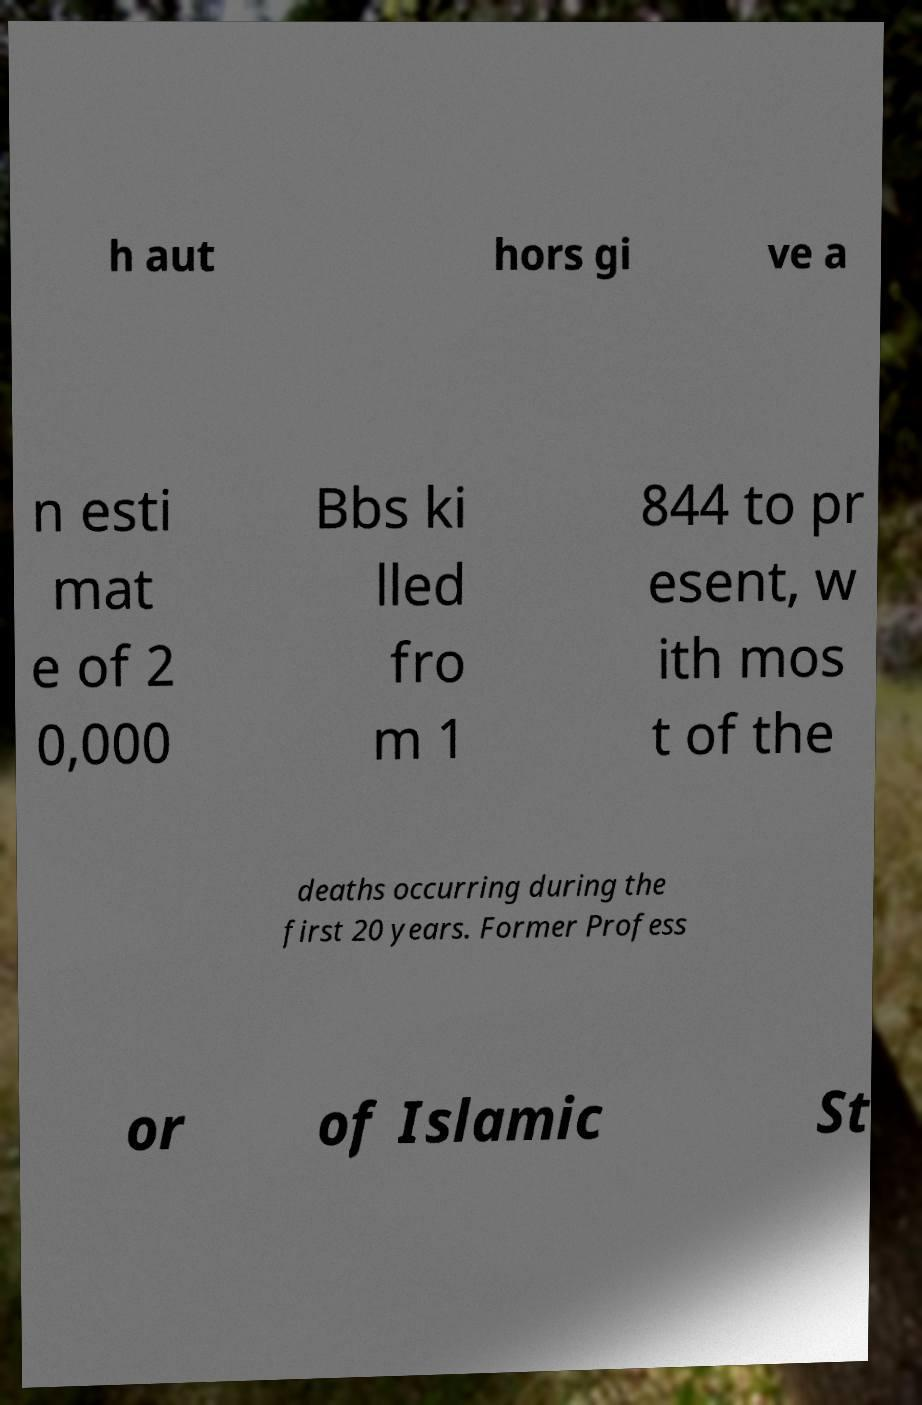Please identify and transcribe the text found in this image. h aut hors gi ve a n esti mat e of 2 0,000 Bbs ki lled fro m 1 844 to pr esent, w ith mos t of the deaths occurring during the first 20 years. Former Profess or of Islamic St 